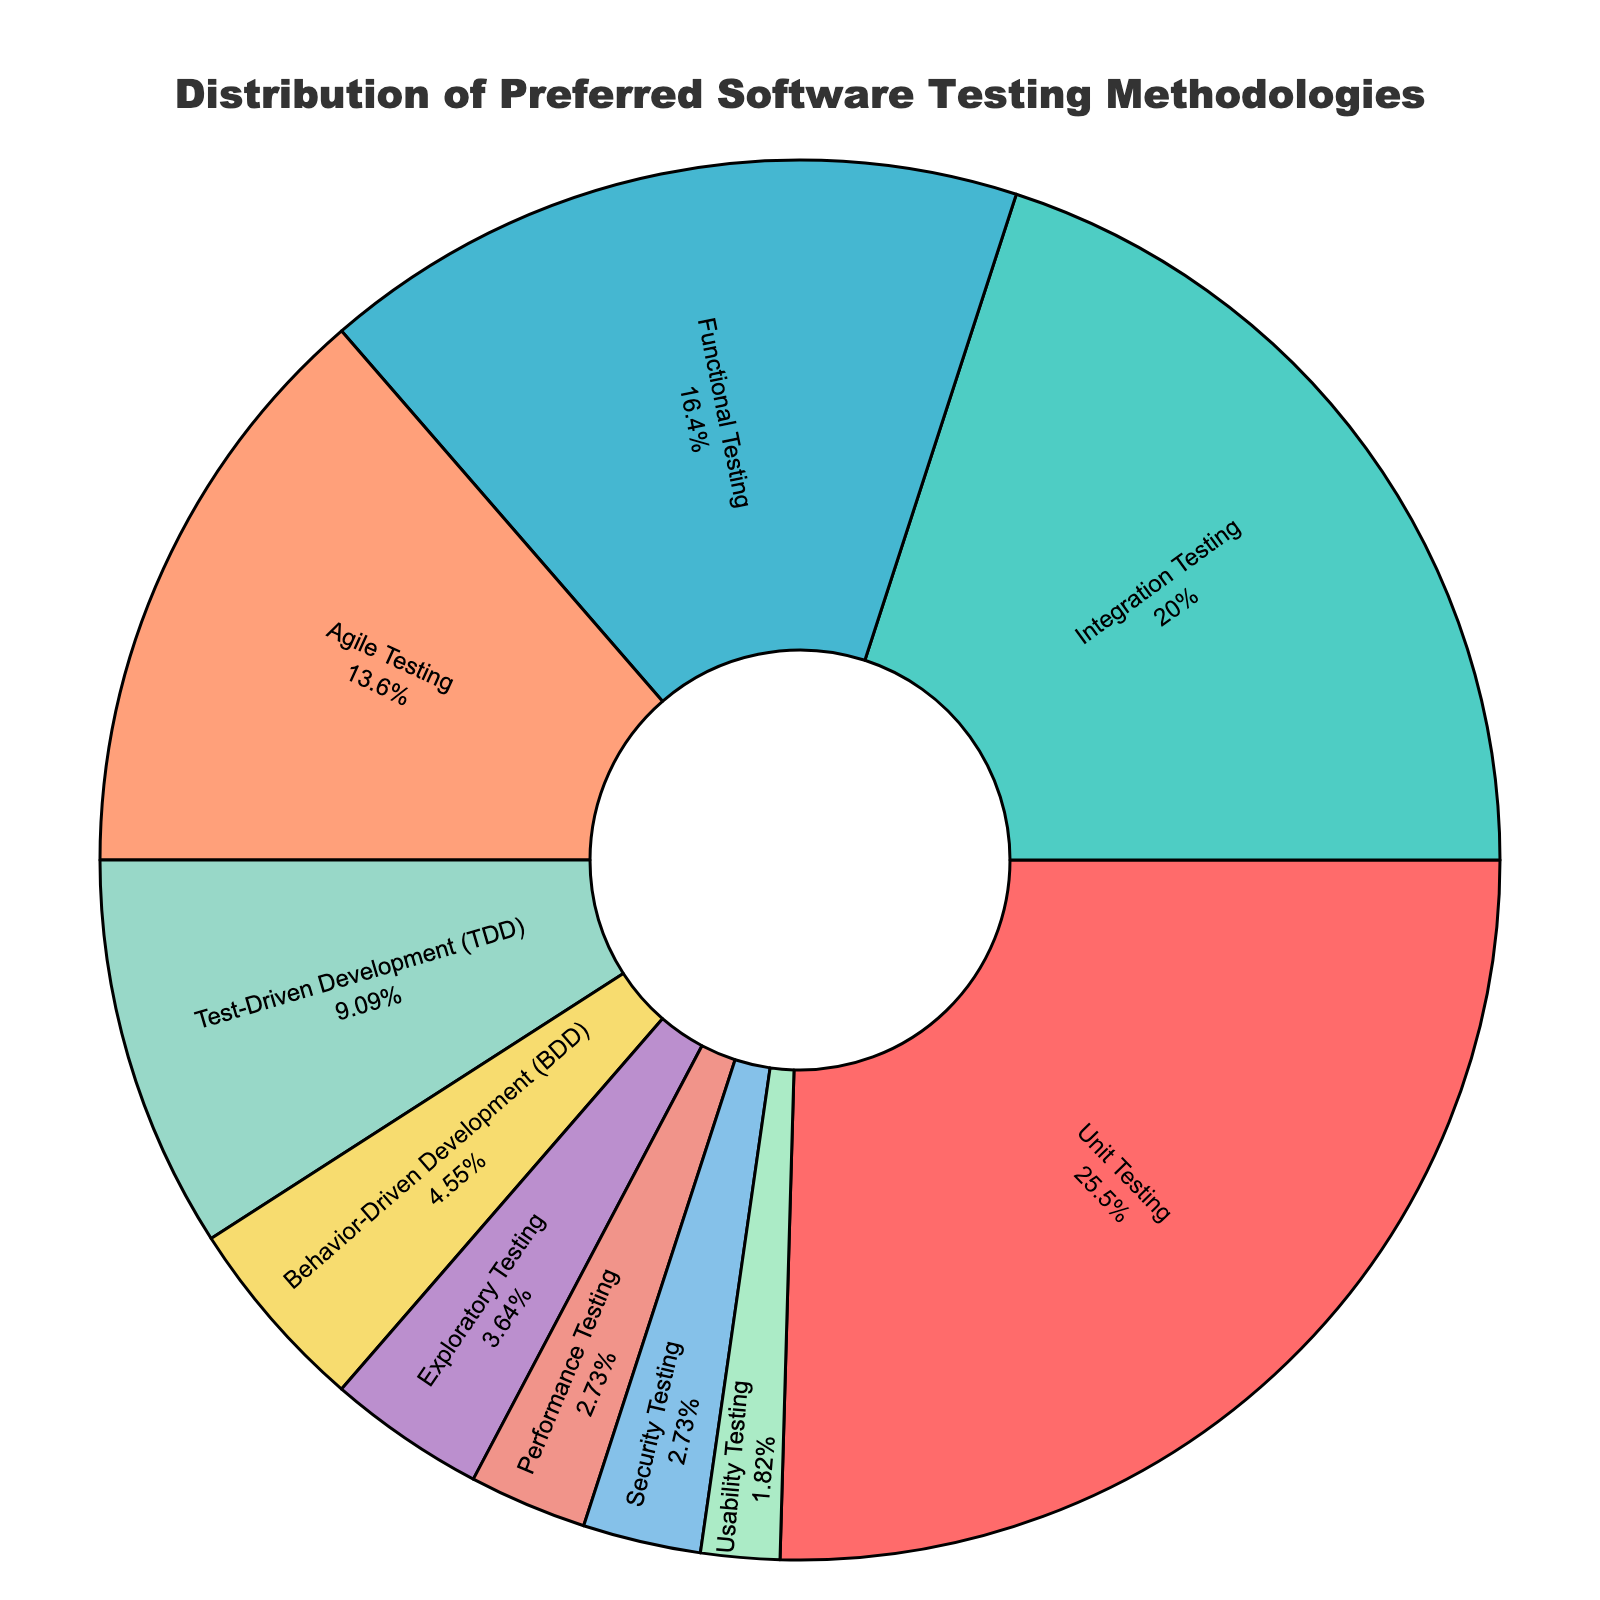Which testing methodology has the highest preference? The pie chart shows different segments for each testing methodology, with percentages indicating their preference. The largest segment with the highest percentage is "Unit Testing" at 28%.
Answer: Unit Testing Which methodologies together make up more than 50% of preferences? To determine this, we sum the percentages from the largest methodologies until the sum exceeds 50%. "Unit Testing" (28%), "Integration Testing" (22%), together make 50%, thus including both makes it more than 50%.
Answer: Unit Testing, Integration Testing What is the difference in preference between Unit Testing and Functional Testing? The percentage for "Unit Testing" is 28%, and for "Functional Testing" it is 18%. Subtracting 18% from 28% gives the difference.
Answer: 10% Which testing methodology has the least preference and what is its percentage? The pie chart shows the smallest segment with the lowest percentage. "Usability Testing" has the smallest segment at 2%.
Answer: Usability Testing, 2% How much more preferred is Integration Testing compared to Test-Driven Development (TDD)? The percentage for "Integration Testing" is 22%, and for "Test-Driven Development (TDD)" it is 10%. Subtracting 10% from 22% gives the difference.
Answer: 12% Are there any methodologies with equal preferences? If yes, which ones and their percentages? Inspecting the pie chart, "Performance Testing" and "Security Testing" both share the same percentage of 3%.
Answer: Performance Testing, Security Testing, 3% What is the combined percentage for Agile Testing and Behavior-Driven Development (BDD)? Agile Testing has a percentage of 15%, and Behavior-Driven Development (BDD) has 5%. Adding these together, 15% + 5% = 20%.
Answer: 20% Which methodology is represented by the green segment and what is its percentage? The green segment represents "Integration Testing" and the pie chart shows its percentage as 22%.
Answer: Integration Testing, 22% What is the average preference percentage for Agile Testing, Test-Driven Development (TDD), and Behavior-Driven Development (BDD)? Adding the percentages of Agile Testing (15%), Test-Driven Development (TDD) (10%), and Behavior-Driven Development (BDD) (5%) gives a total of 30%. Dividing by the number of methodologies (3) results in an average of 10%.
Answer: 10% How much more preferred is Functional Testing compared to Usability Testing? The percentage for Functional Testing is 18%, and for Usability Testing it is 2%. Subtracting 2% from 18% gives 16%.
Answer: 16% 